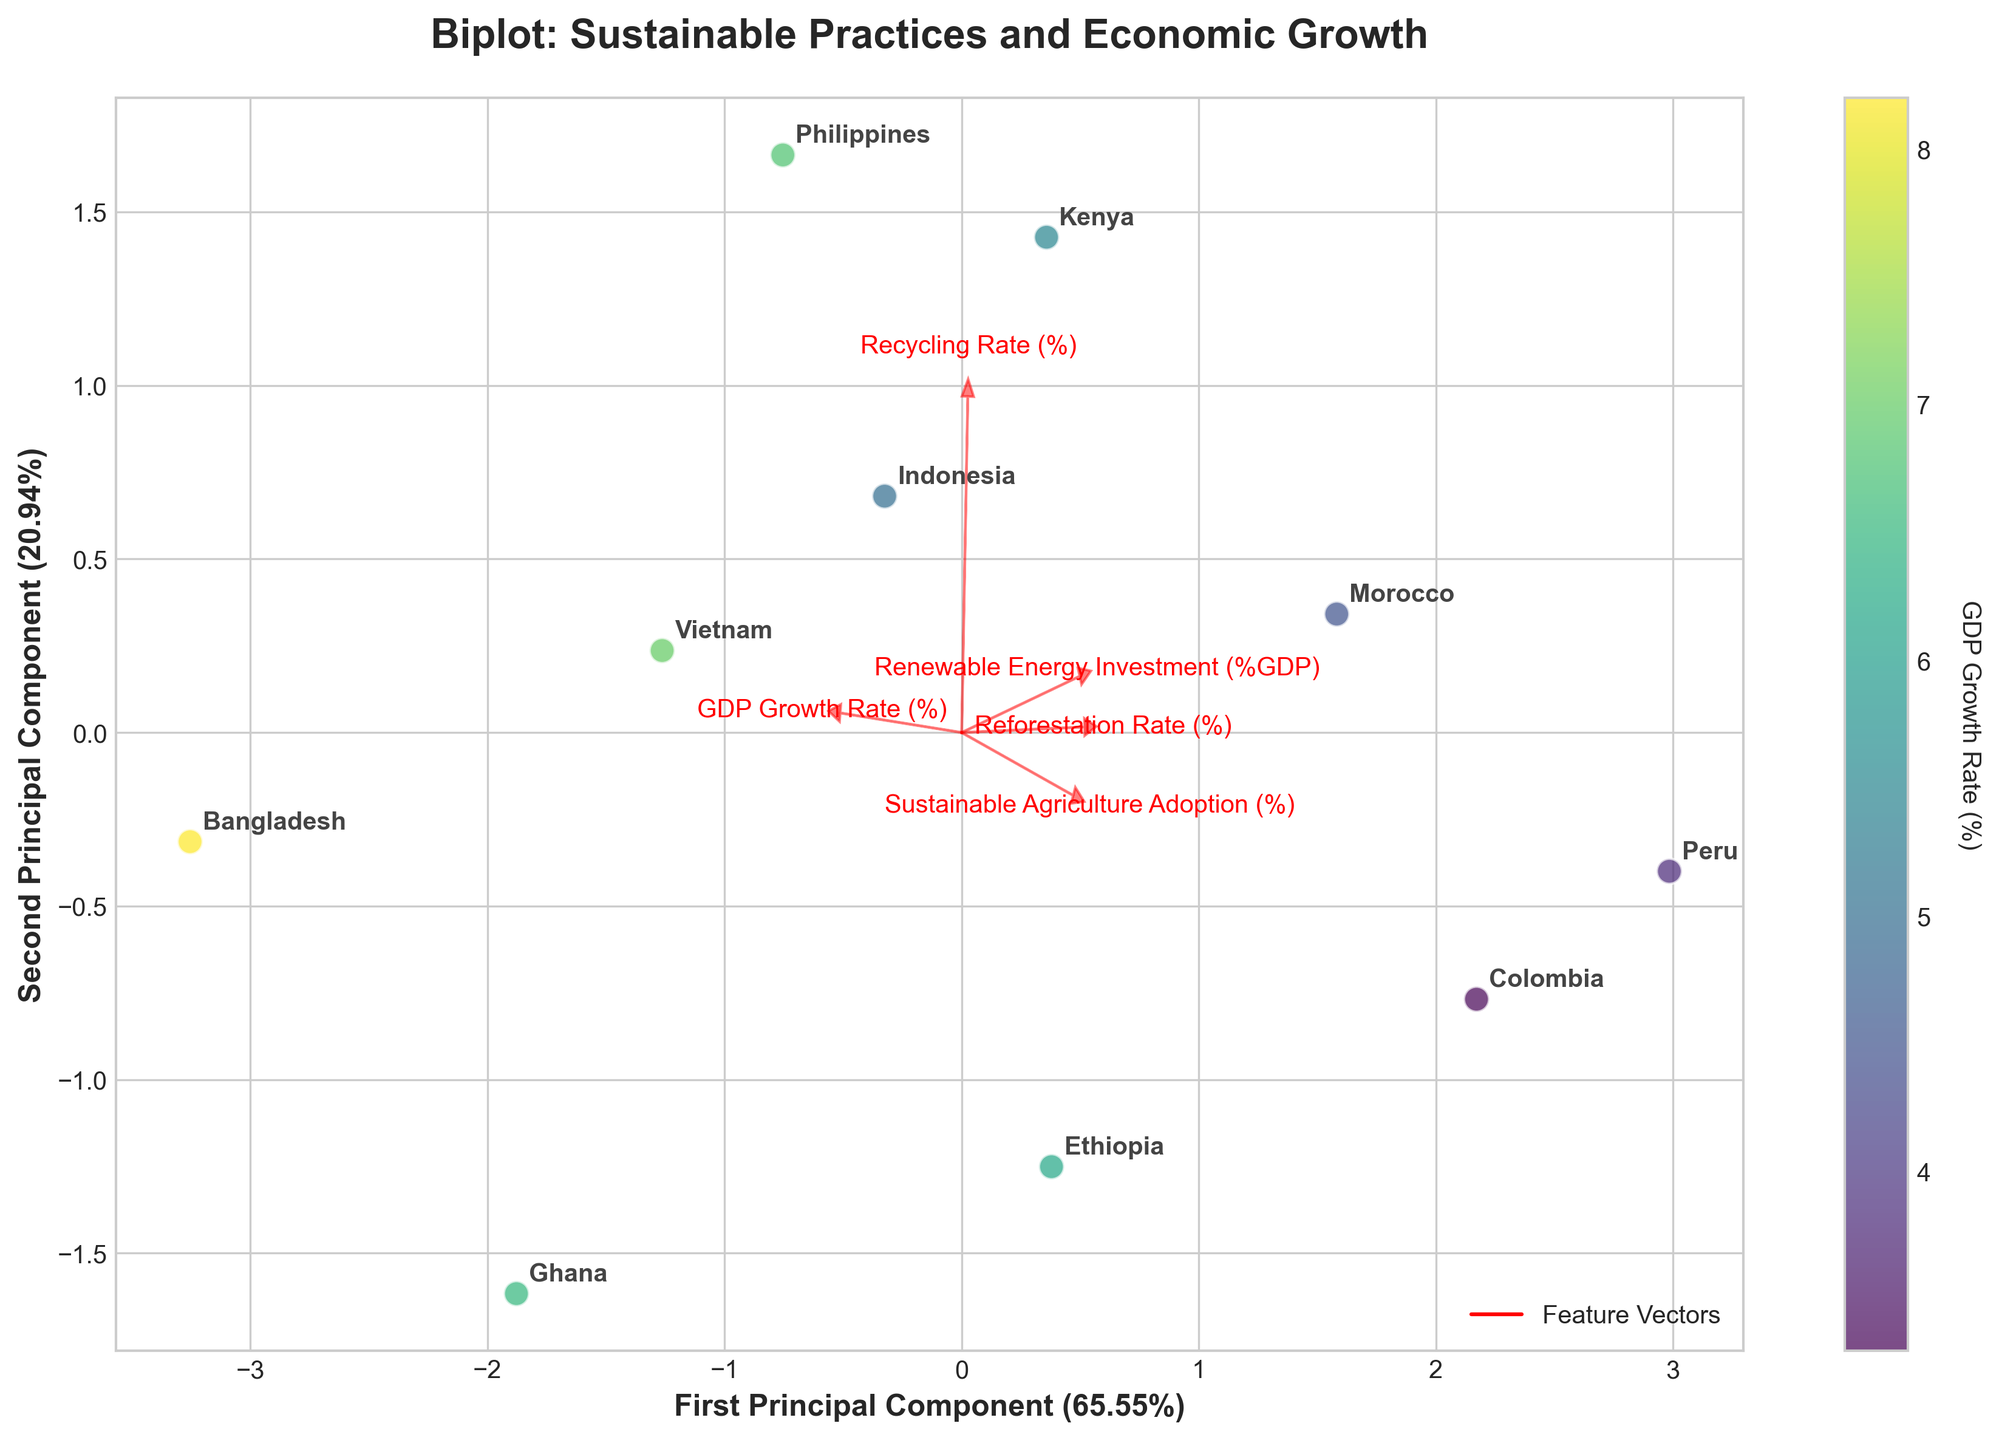What is the title of the biplot? The title is displayed at the top of the figure. It indicates what the figure is about.
Answer: Biplot: Sustainable Practices and Economic Growth How many countries are represented in the biplot? There are 10 data points, each representing a country. This count corresponds to the number of labeled points in the scatter plot.
Answer: 10 Which country has the highest GDP growth rate according to the color bar? The colors represent GDP growth rates. The darkest point on the color spectrum refers to Bangladesh.
Answer: Bangladesh What percentage of variance is explained by the first principal component? The percentage is given on the x-axis's label, which specifies the contribution of the first principal component.
Answer: 40.28% Which two countries are closest to each other in the biplot? By examining the spatial distance between points, Ethiopia and Kenya appear to be closest to each other.
Answer: Ethiopia and Kenya Which feature is most aligned with the first principal component? The feature vector most aligned with the x-axis (First Principal Component) indicates its strong significance in explaining the variance. Renewable Energy Investment (%GDP) is most aligned.
Answer: Renewable Energy Investment (%GDP) How does the reforestation rate compare between Peru and Ghana? Comparing the reforestation rate arrows: Peru is higher along this axis than Ghana.
Answer: Peru has a higher reforestation rate than Ghana Among the countries, which has the lowest recycling rate? The vertical position of each country's label in the plot with respect to the Recycling Rate vector helps identify the one with the lowest value.
Answer: Ghana What is the second principal component's contribution to the variance? The percentage is given on the y-axis's label, which specifies the contribution of the second principal component.
Answer: 25.83% How are GDP growth rates visually differentiated in the biplot? The color mapping of data points reflects varying GDP growth rates, as indicated by the color bar along a viridis color scale.
Answer: By color mapping 